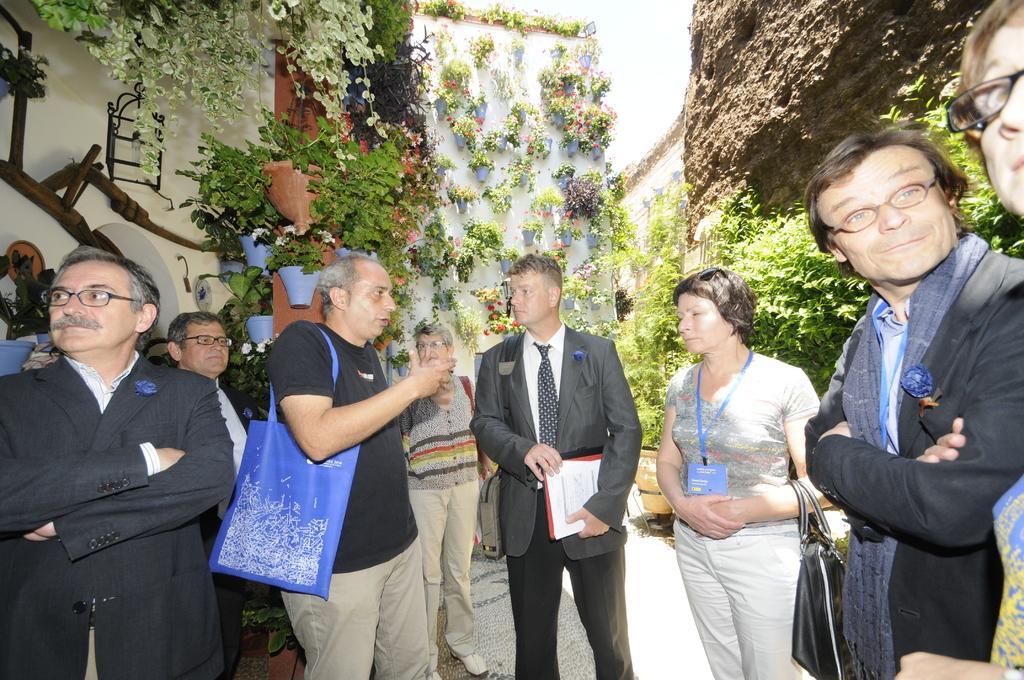Could you give a brief overview of what you see in this image? In this image few persons are standing on the floor. Left side there is a person wearing spectacles. Beside him there is a person wearing spectacles. Middle of the image there is a person holding few papers and he is carrying a bag. Right side there are few plants. Behind there is a rock. Left side few photos are attached to the wall. Pots are having plants in it. 